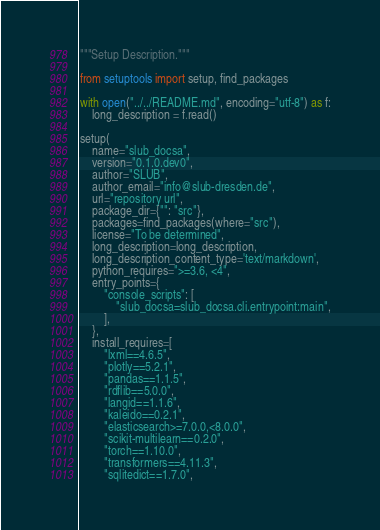<code> <loc_0><loc_0><loc_500><loc_500><_Python_>"""Setup Description."""

from setuptools import setup, find_packages

with open("../../README.md", encoding="utf-8") as f:
    long_description = f.read()

setup(
    name="slub_docsa",
    version="0.1.0.dev0",
    author="SLUB",
    author_email="info@slub-dresden.de",
    url="repository url",
    package_dir={"": "src"},
    packages=find_packages(where="src"),
    license="To be determined",
    long_description=long_description,
    long_description_content_type='text/markdown',
    python_requires=">=3.6, <4",
    entry_points={
        "console_scripts": [
            "slub_docsa=slub_docsa.cli.entrypoint:main",
        ],
    },
    install_requires=[
        "lxml==4.6.5",
        "plotly==5.2.1",
        "pandas==1.1.5",
        "rdflib==5.0.0",
        "langid==1.1.6",
        "kaleido==0.2.1",
        "elasticsearch>=7.0.0,<8.0.0",
        "scikit-multilearn==0.2.0",
        "torch==1.10.0",
        "transformers==4.11.3",
        "sqlitedict==1.7.0",</code> 